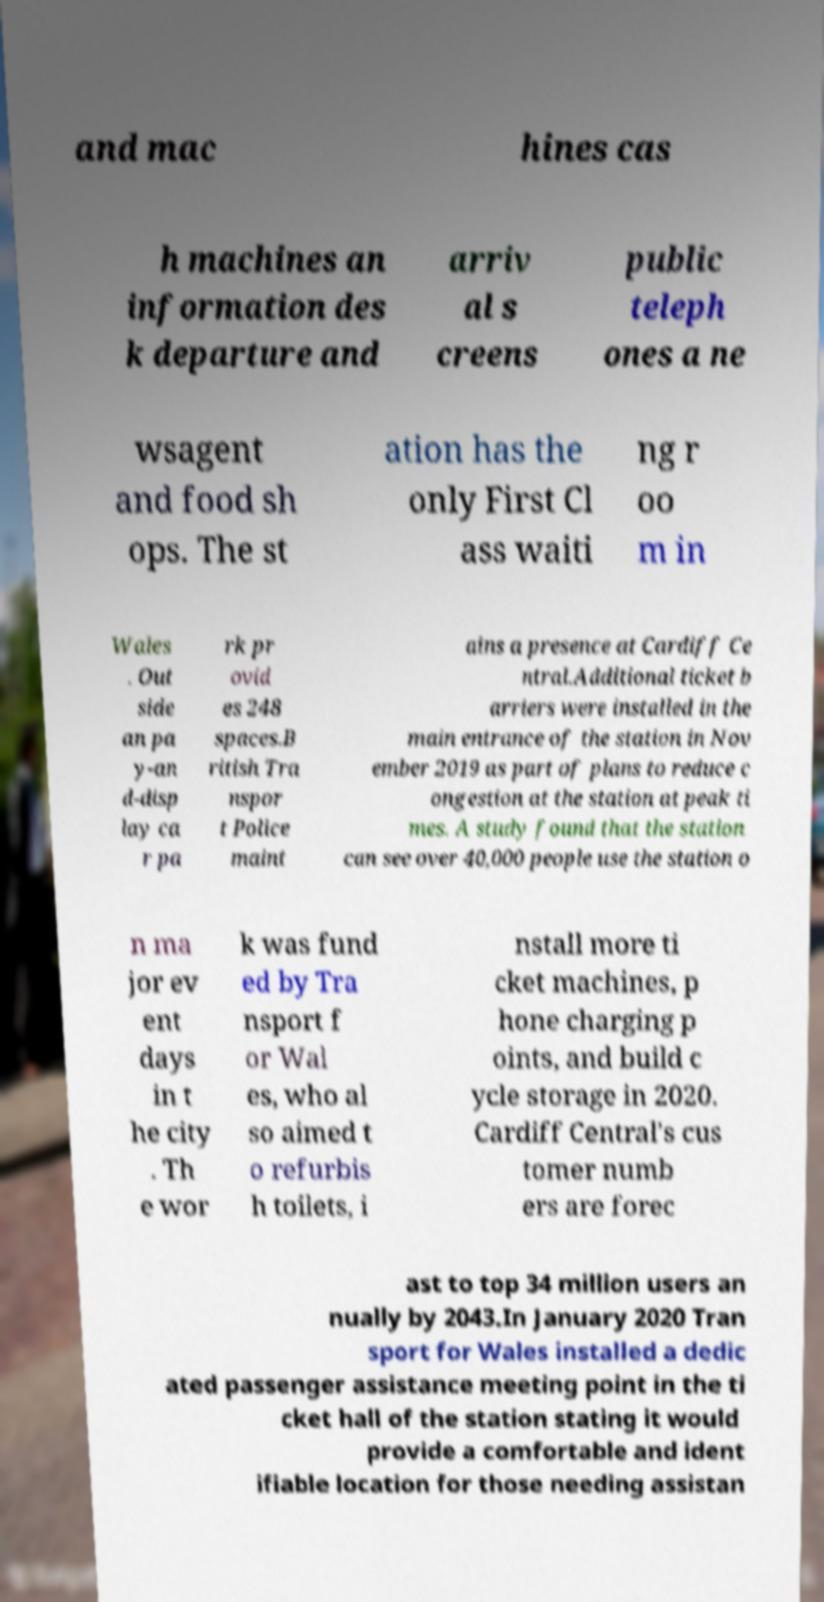Please identify and transcribe the text found in this image. and mac hines cas h machines an information des k departure and arriv al s creens public teleph ones a ne wsagent and food sh ops. The st ation has the only First Cl ass waiti ng r oo m in Wales . Out side an pa y-an d-disp lay ca r pa rk pr ovid es 248 spaces.B ritish Tra nspor t Police maint ains a presence at Cardiff Ce ntral.Additional ticket b arriers were installed in the main entrance of the station in Nov ember 2019 as part of plans to reduce c ongestion at the station at peak ti mes. A study found that the station can see over 40,000 people use the station o n ma jor ev ent days in t he city . Th e wor k was fund ed by Tra nsport f or Wal es, who al so aimed t o refurbis h toilets, i nstall more ti cket machines, p hone charging p oints, and build c ycle storage in 2020. Cardiff Central's cus tomer numb ers are forec ast to top 34 million users an nually by 2043.In January 2020 Tran sport for Wales installed a dedic ated passenger assistance meeting point in the ti cket hall of the station stating it would provide a comfortable and ident ifiable location for those needing assistan 